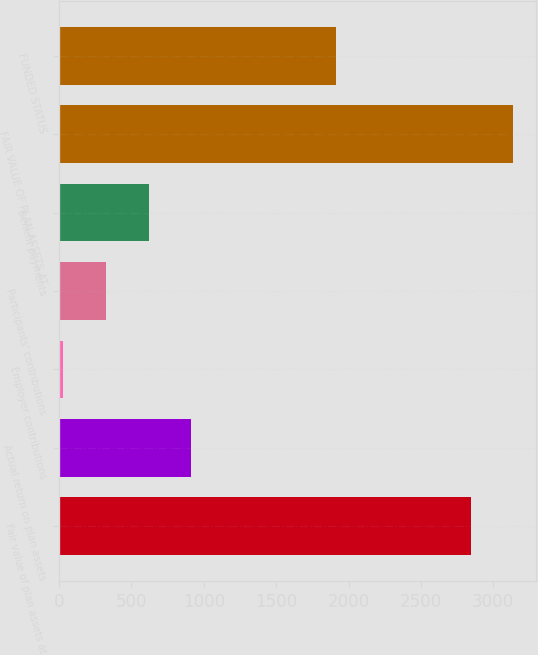Convert chart. <chart><loc_0><loc_0><loc_500><loc_500><bar_chart><fcel>Fair value of plan assets at<fcel>Actual return on plan assets<fcel>Employer contributions<fcel>Participants' contributions<fcel>Benefit payments<fcel>FAIR VALUE OF PLAN ASSETS AT<fcel>FUNDED STATUS<nl><fcel>2843<fcel>912.8<fcel>29<fcel>323.6<fcel>618.2<fcel>3137.6<fcel>1911<nl></chart> 